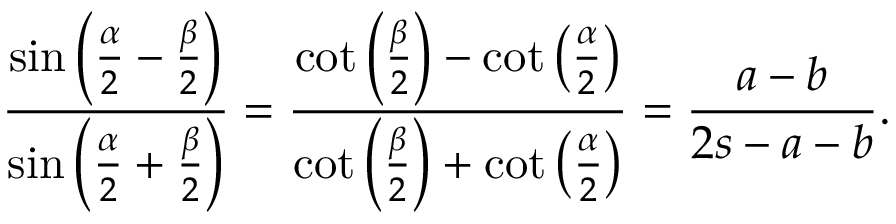<formula> <loc_0><loc_0><loc_500><loc_500>{ \frac { \sin \left ( { \frac { \alpha } { 2 } } - { \frac { \beta } { 2 } } \right ) } { \sin \left ( { \frac { \alpha } { 2 } } + { \frac { \beta } { 2 } } \right ) } } = { \frac { \cot \left ( { \frac { \beta } { 2 } } \right ) - \cot \left ( { \frac { \alpha } { 2 } } \right ) } { \cot \left ( { \frac { \beta } { 2 } } \right ) + \cot \left ( { \frac { \alpha } { 2 } } \right ) } } = { \frac { a - b } { 2 s - a - b } } .</formula> 